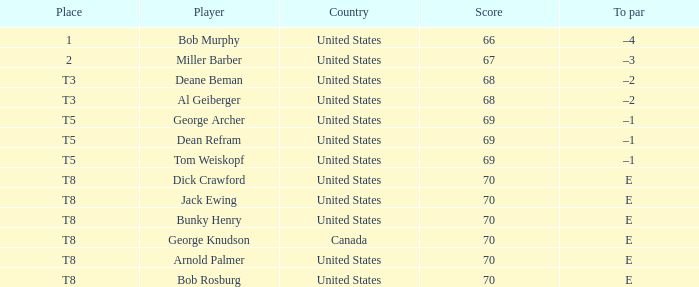When bunky henry from the united states achieved a score above 68 and had a to par of e, what was his ranking? T8. 